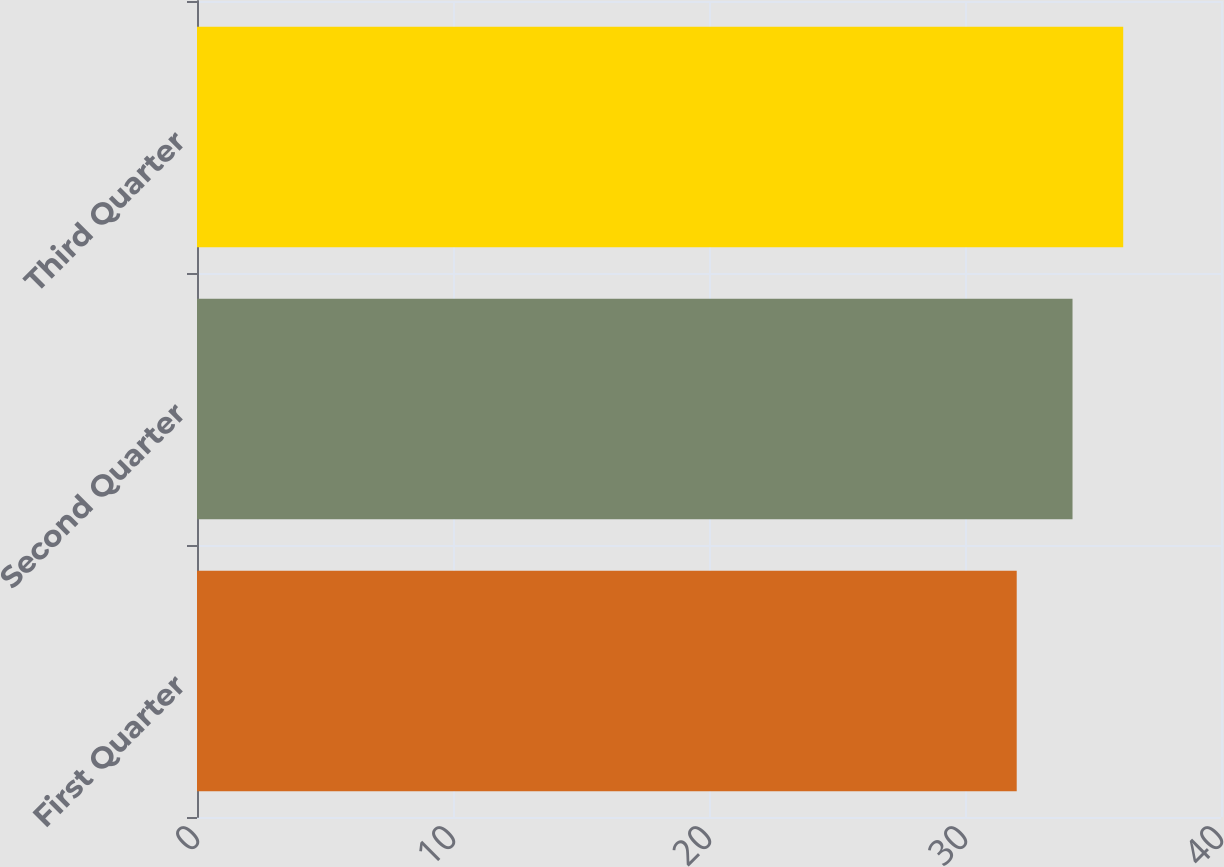Convert chart. <chart><loc_0><loc_0><loc_500><loc_500><bar_chart><fcel>First Quarter<fcel>Second Quarter<fcel>Third Quarter<nl><fcel>32.02<fcel>34.2<fcel>36.18<nl></chart> 